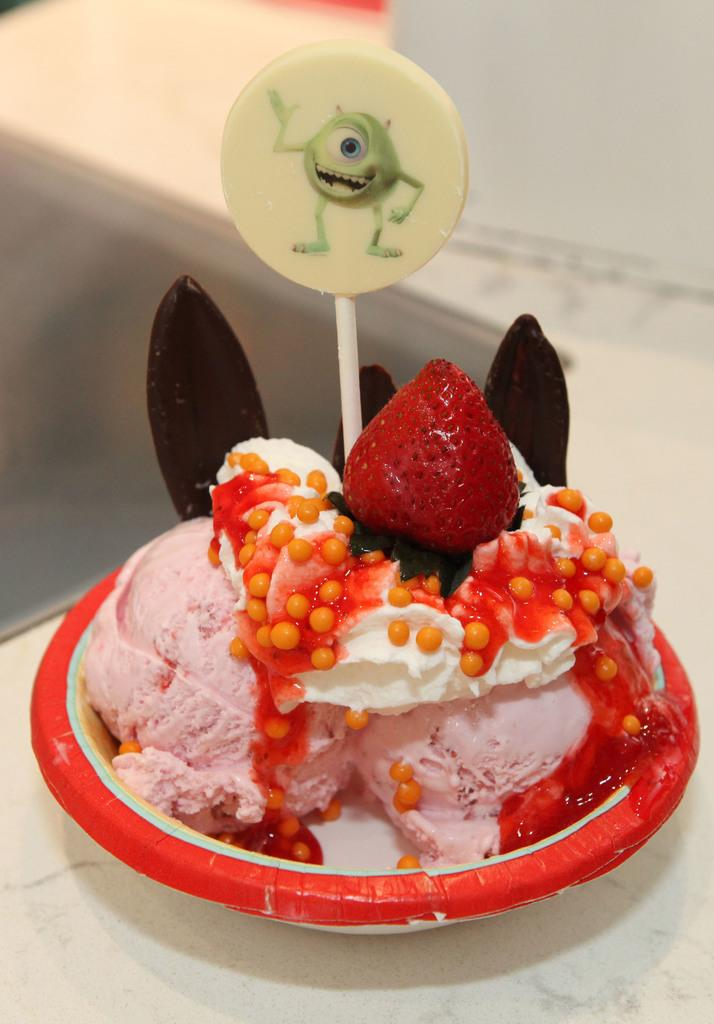What is in the bowl that is visible in the image? There is a bowl of ice cream in the image. What is placed above the ice cream in the image? There is a strawberry above the ice cream. Where is the bowl of ice cream located in the image? The bowl of ice cream is on a table. What type of candy is visible in the ice cream? There is a lollipop in the middle of the ice cream. What type of pump is used to create the ice cream in the image? There is no pump present in the image, and the method of creating the ice cream is not mentioned. 